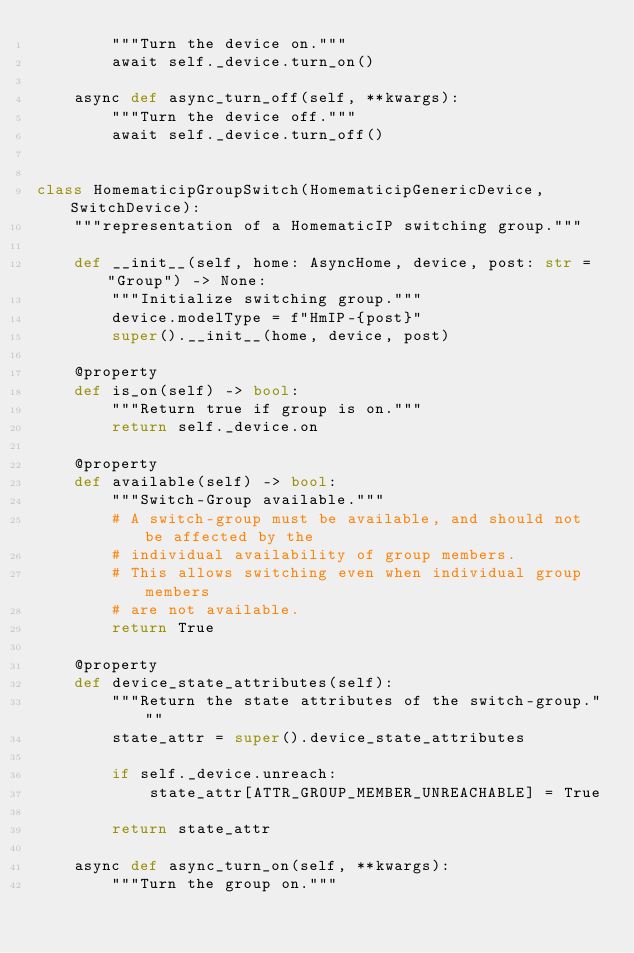<code> <loc_0><loc_0><loc_500><loc_500><_Python_>        """Turn the device on."""
        await self._device.turn_on()

    async def async_turn_off(self, **kwargs):
        """Turn the device off."""
        await self._device.turn_off()


class HomematicipGroupSwitch(HomematicipGenericDevice, SwitchDevice):
    """representation of a HomematicIP switching group."""

    def __init__(self, home: AsyncHome, device, post: str = "Group") -> None:
        """Initialize switching group."""
        device.modelType = f"HmIP-{post}"
        super().__init__(home, device, post)

    @property
    def is_on(self) -> bool:
        """Return true if group is on."""
        return self._device.on

    @property
    def available(self) -> bool:
        """Switch-Group available."""
        # A switch-group must be available, and should not be affected by the
        # individual availability of group members.
        # This allows switching even when individual group members
        # are not available.
        return True

    @property
    def device_state_attributes(self):
        """Return the state attributes of the switch-group."""
        state_attr = super().device_state_attributes

        if self._device.unreach:
            state_attr[ATTR_GROUP_MEMBER_UNREACHABLE] = True

        return state_attr

    async def async_turn_on(self, **kwargs):
        """Turn the group on."""</code> 